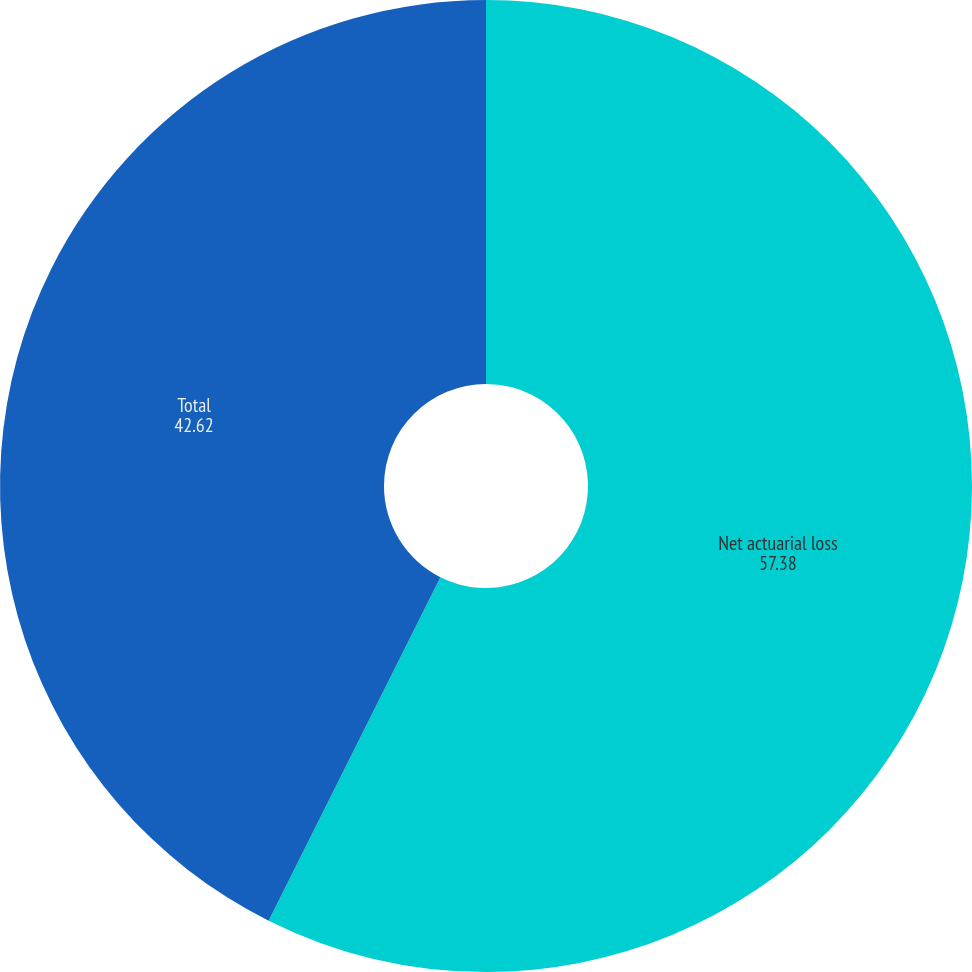<chart> <loc_0><loc_0><loc_500><loc_500><pie_chart><fcel>Net actuarial loss<fcel>Total<nl><fcel>57.38%<fcel>42.62%<nl></chart> 